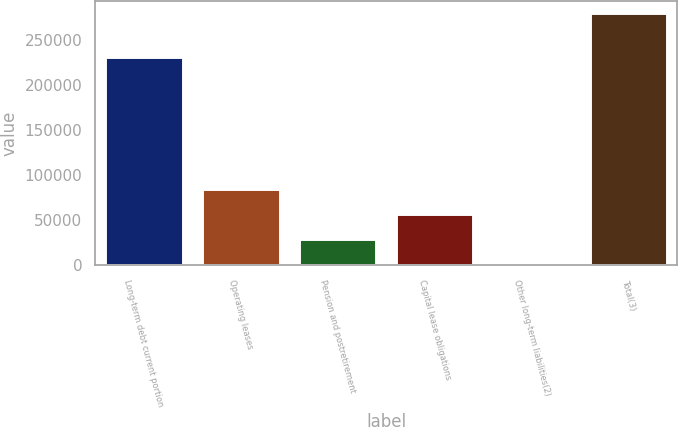<chart> <loc_0><loc_0><loc_500><loc_500><bar_chart><fcel>Long-term debt current portion<fcel>Operating leases<fcel>Pension and postretirement<fcel>Capital lease obligations<fcel>Other long-term liabilities(2)<fcel>Total(3)<nl><fcel>230706<fcel>84713.8<fcel>29080.6<fcel>56897.2<fcel>1264<fcel>279430<nl></chart> 